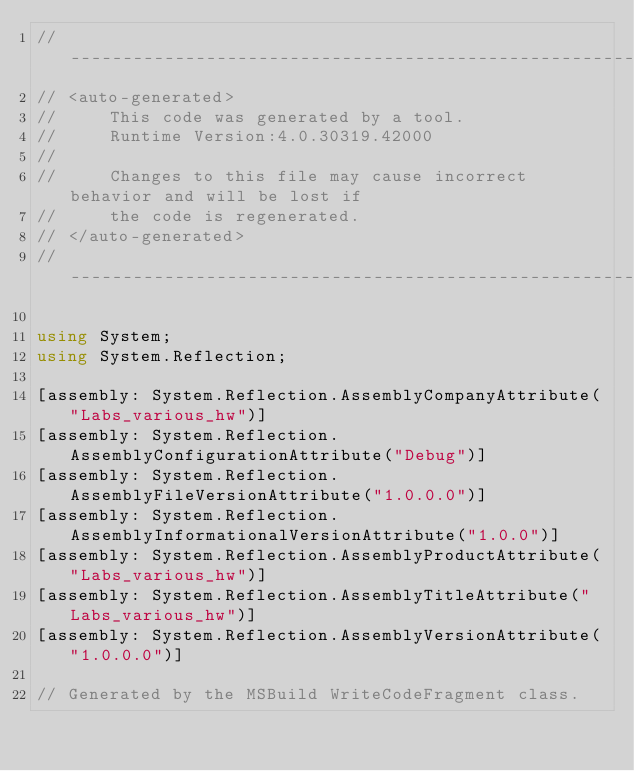Convert code to text. <code><loc_0><loc_0><loc_500><loc_500><_C#_>//------------------------------------------------------------------------------
// <auto-generated>
//     This code was generated by a tool.
//     Runtime Version:4.0.30319.42000
//
//     Changes to this file may cause incorrect behavior and will be lost if
//     the code is regenerated.
// </auto-generated>
//------------------------------------------------------------------------------

using System;
using System.Reflection;

[assembly: System.Reflection.AssemblyCompanyAttribute("Labs_various_hw")]
[assembly: System.Reflection.AssemblyConfigurationAttribute("Debug")]
[assembly: System.Reflection.AssemblyFileVersionAttribute("1.0.0.0")]
[assembly: System.Reflection.AssemblyInformationalVersionAttribute("1.0.0")]
[assembly: System.Reflection.AssemblyProductAttribute("Labs_various_hw")]
[assembly: System.Reflection.AssemblyTitleAttribute("Labs_various_hw")]
[assembly: System.Reflection.AssemblyVersionAttribute("1.0.0.0")]

// Generated by the MSBuild WriteCodeFragment class.

</code> 